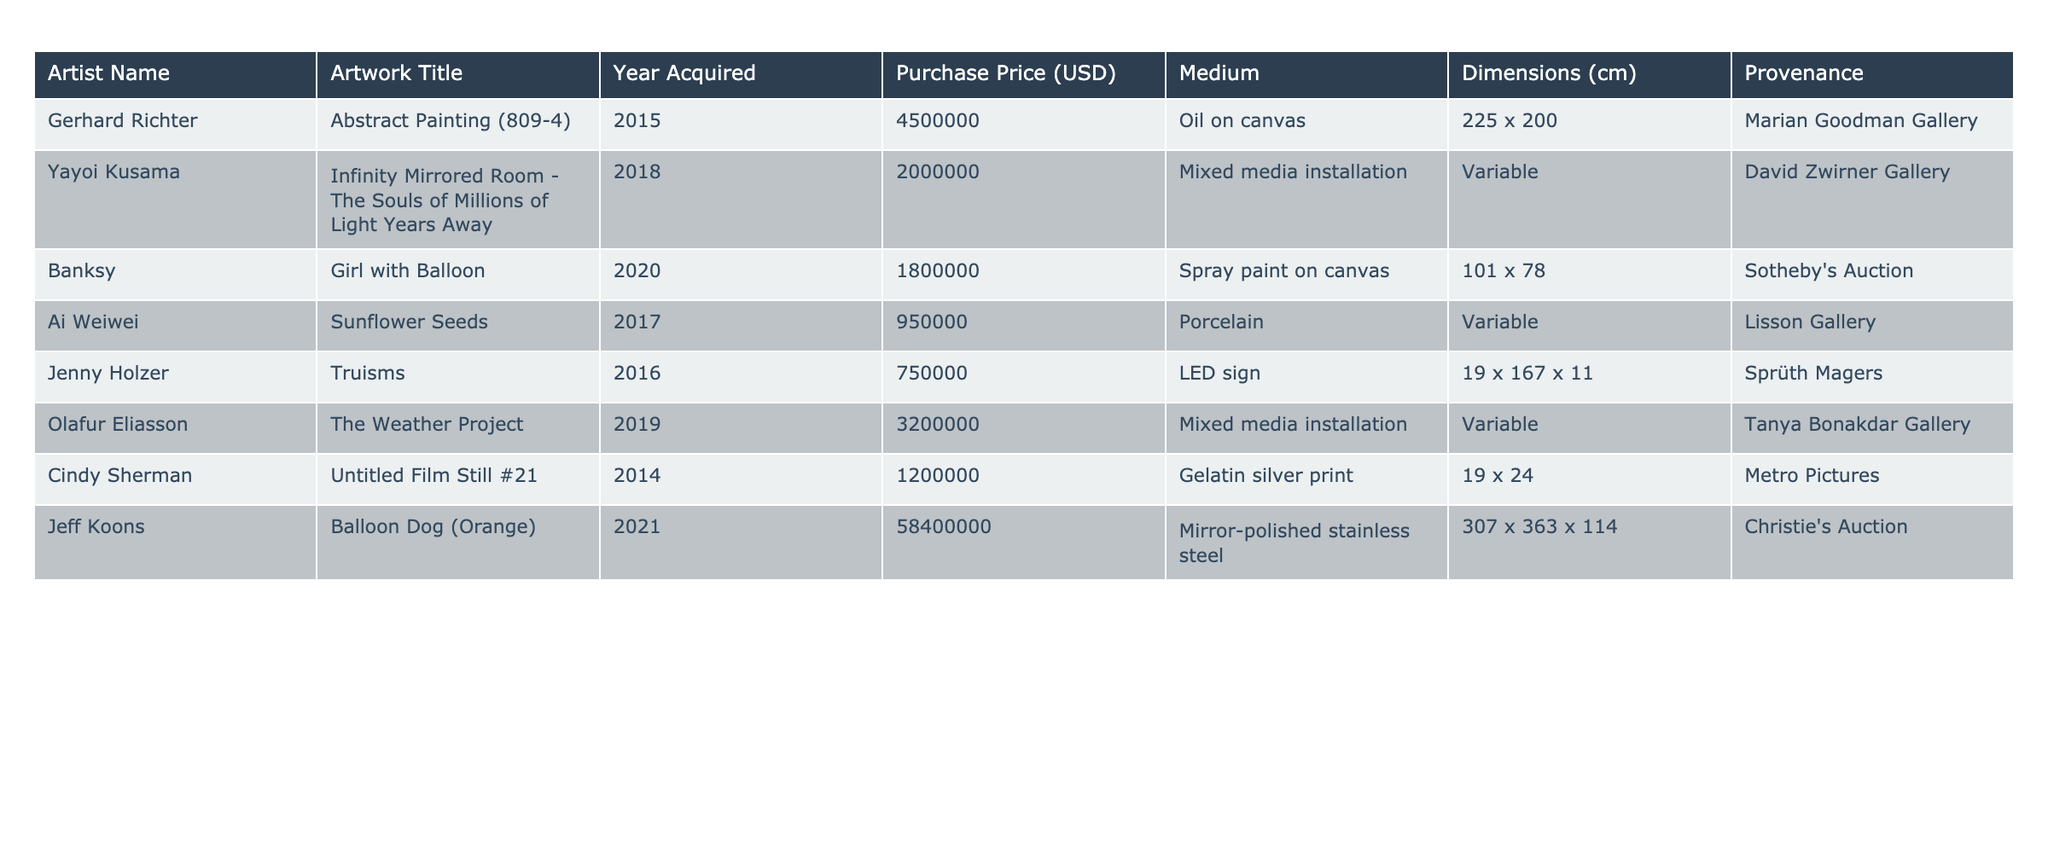What is the purchase price of "Girl with Balloon"? The table lists the purchase price for "Girl with Balloon," which is shown under the corresponding column. The value is 1,800,000 USD.
Answer: 1,800,000 USD Who is the artist of the artwork titled "Sunflower Seeds"? By looking at the table, you can identify the artist associated with "Sunflower Seeds." The artist's name appears in the column next to the artwork title. The artist is Ai Weiwei.
Answer: Ai Weiwei What medium is used for "The Weather Project"? The medium for "The Weather Project" is found in the medium column associated with that artwork. It states that the medium is mixed media installation.
Answer: Mixed media installation What was the year of acquisition for "Untitled Film Still #21"? To find the year of acquisition for "Untitled Film Still #21," you can check the year acquired column next to that artwork. It shows the year 2014.
Answer: 2014 Which artwork has the largest purchase price? By comparing the purchase prices from the table, "Balloon Dog (Orange)" has the highest purchase price of 58,400,000 USD.
Answer: Balloon Dog (Orange) What is the average purchase price of all artworks in the table? The total purchase price is calculated by summing all individual prices: 4,500,000 + 2,000,000 + 1,800,000 + 950,000 + 750,000 + 3,200,000 + 1,200,000 + 58,400,000 = 72,950,000. With 8 artworks, the average is 72,950,000 / 8 = 9,118,750.
Answer: 9,118,750 Compare the years acquired for the artworks by Yayoi Kusama and Jeff Koons. Which artist acquired their artwork more recently? Yayoi Kusama's artwork was acquired in 2018, and Jeff Koons' in 2021. Comparing the two years shows that 2021 is later than 2018, so Jeff Koons acquired his artwork more recently.
Answer: Jeff Koons Is there any artwork that has a variable dimension? Checking the dimensions column, both "Infinity Mirrored Room - The Souls of Millions of Light Years Away" and "Sunflower Seeds" state their dimensions as variable. Therefore, yes, there are artworks with variable dimensions.
Answer: Yes What is the total number of artworks acquired from auction houses? The table mentions two artworks acquired from auction houses: "Girl with Balloon" from Sotheby's and "Balloon Dog (Orange)" from Christie's. Therefore, the total is 2.
Answer: 2 Which artwork has the smallest dimensions listed in the table? By checking the dimensions column, "Truisms" has dimensions listed as 19 x 167 x 11, which is the smallest among all entries.
Answer: Truisms What is the provenance of "Abstract Painting (809-4)"? The provenance for "Abstract Painting (809-4)" can be found in the provenance column next to the artwork's title. It is attributed to Marian Goodman Gallery.
Answer: Marian Goodman Gallery 